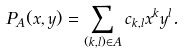<formula> <loc_0><loc_0><loc_500><loc_500>P _ { A } ( x , y ) = \sum _ { ( k , l ) \in A } c _ { k , l } x ^ { k } y ^ { l } .</formula> 